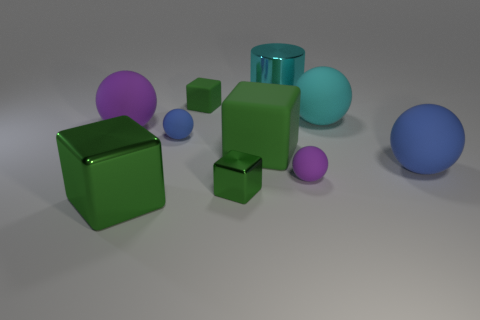How many objects are there in total, and can you describe their colors and shapes? There are a total of 8 objects in the image, consisting of a variety of colors and shapes. There are 2 spheres, one large cyan rubber ball and one smaller blue matte sphere; 1 cylinder with a shiny cyan surface; 2 cubes, one larger green glass cube and a smaller one; and 3 smaller purple matte objects of varying geometric shapes, including a sphere, a cube, and an object resembling a capsule or pill shape. 